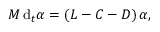<formula> <loc_0><loc_0><loc_500><loc_500>M \, d _ { t } \alpha = \left ( L - C - D \right ) \alpha ,</formula> 